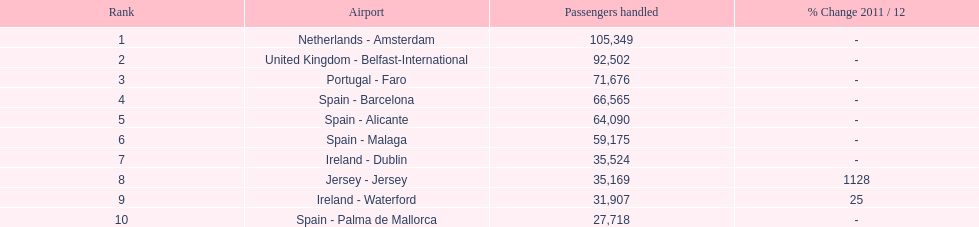What is the average number of passengers managed on the top 10 busiest routes to and from london southend airport? 58,967.5. 